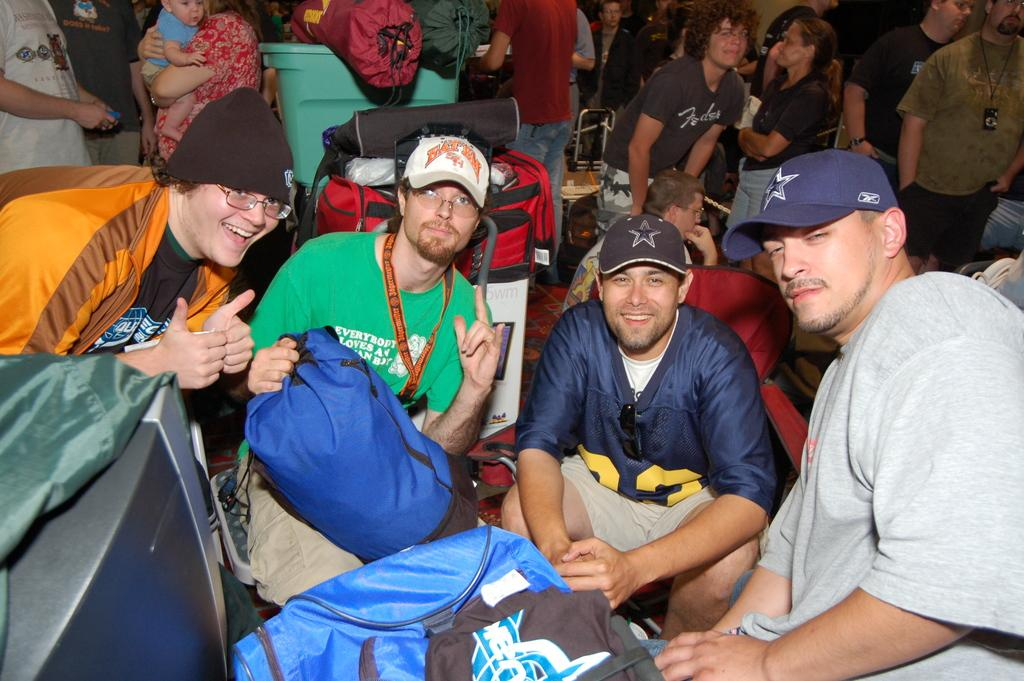How many men are sitting in the center of the image? There are three men sitting in the center of the image. What is the position of the man on the left side of the image? There is a man on the left side of the image. Can you describe the background of the image? There are people and luggages in the background of the image, along with trolleys. What type of bed can be seen in the image? There is no bed present in the image. How does the sleet affect the visibility of the people in the background of the image? There is no mention of sleet in the image, and therefore it cannot affect the visibility of the people in the background. 